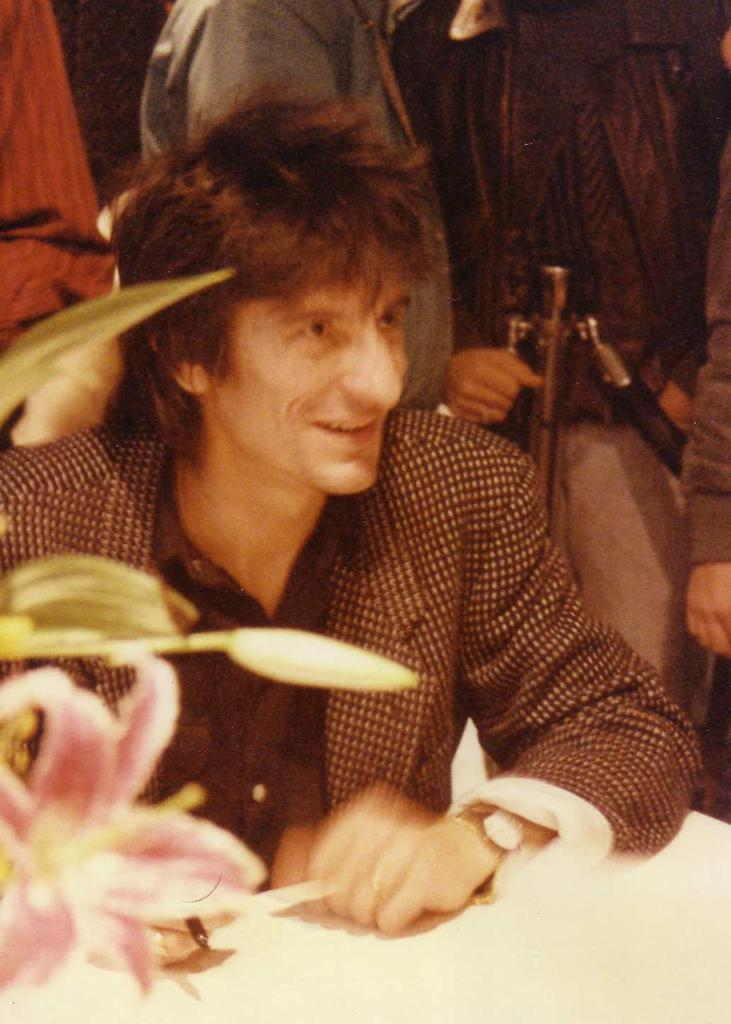What is the man in the image doing? The man is sitting in the image. What expression does the man have? The man is smiling. Can you describe the people in the background of the image? There are people standing in the background of the image. What type of frog can be seen hopping in the image? There is no frog present in the image. Can you describe the trail that the squirrel is following in the image? There is no squirrel or trail present in the image. 